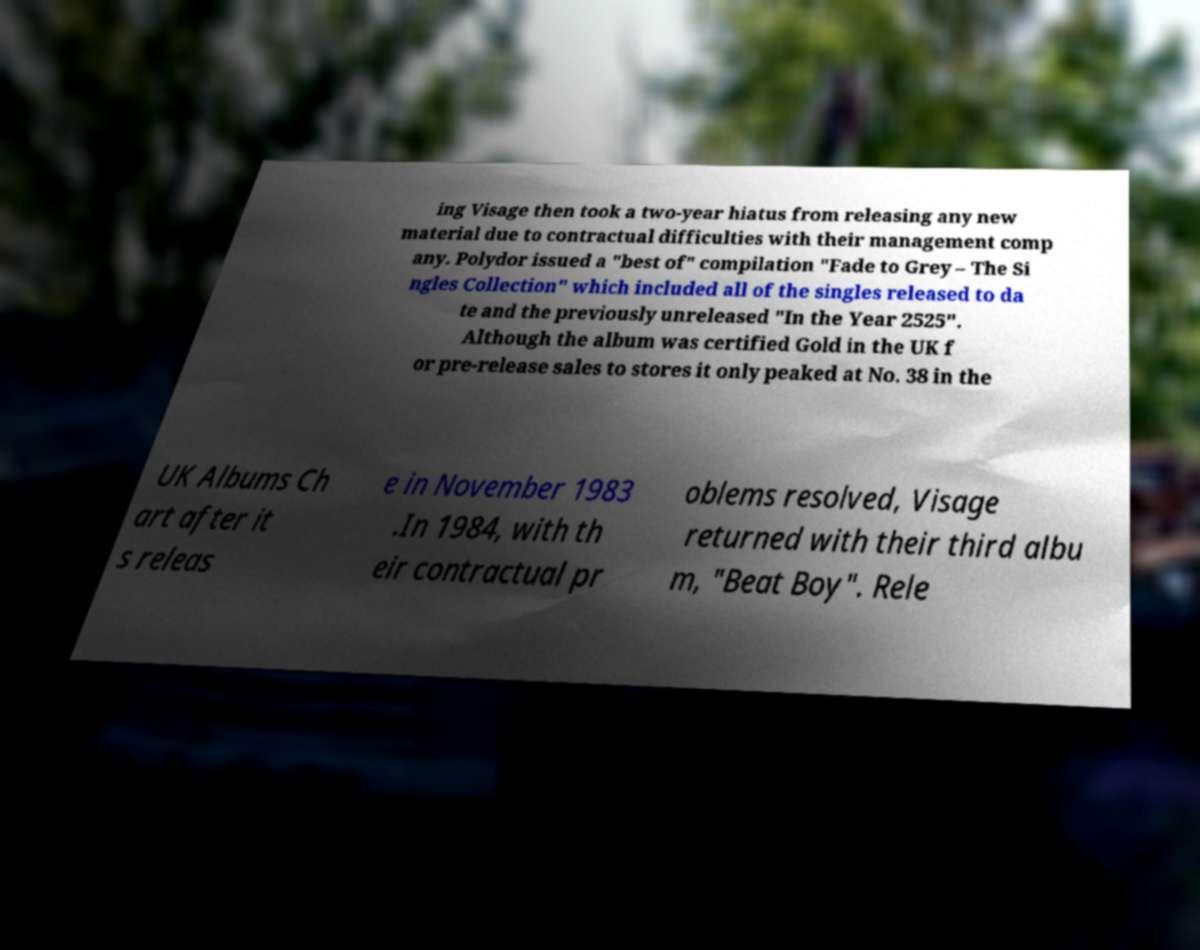Could you extract and type out the text from this image? ing Visage then took a two-year hiatus from releasing any new material due to contractual difficulties with their management comp any. Polydor issued a "best of" compilation "Fade to Grey – The Si ngles Collection" which included all of the singles released to da te and the previously unreleased "In the Year 2525". Although the album was certified Gold in the UK f or pre-release sales to stores it only peaked at No. 38 in the UK Albums Ch art after it s releas e in November 1983 .In 1984, with th eir contractual pr oblems resolved, Visage returned with their third albu m, "Beat Boy". Rele 